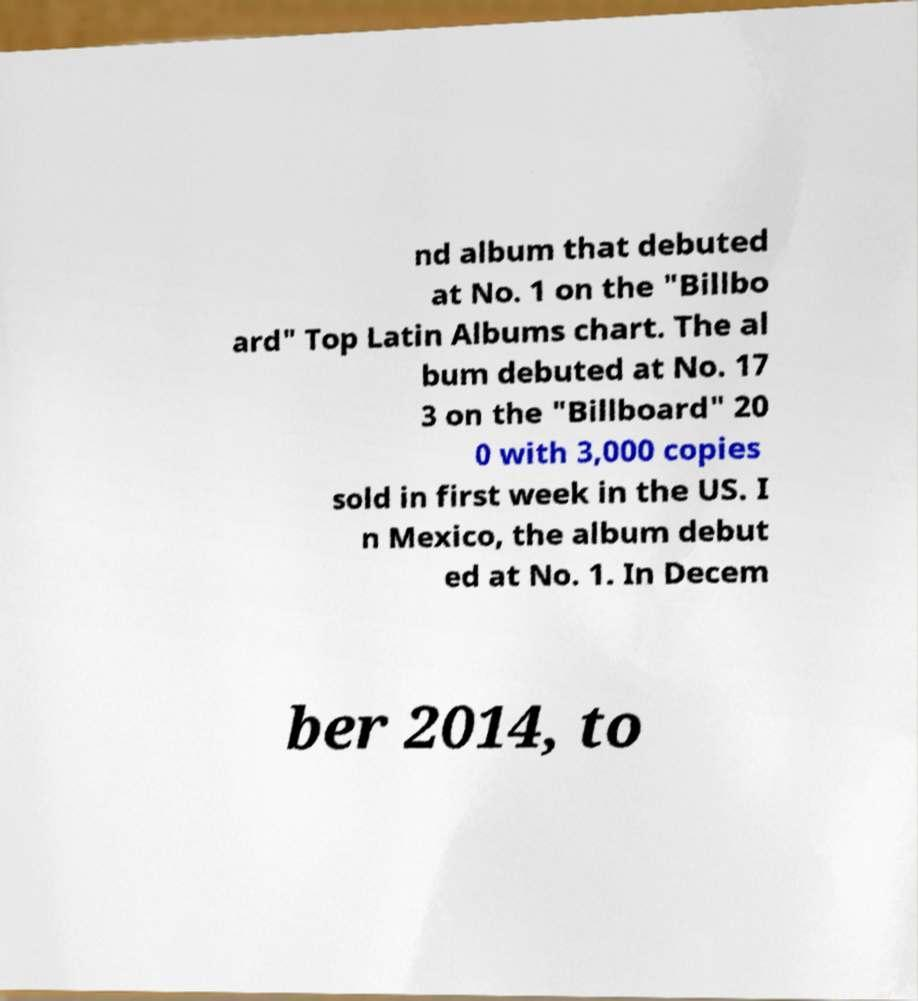What messages or text are displayed in this image? I need them in a readable, typed format. nd album that debuted at No. 1 on the "Billbo ard" Top Latin Albums chart. The al bum debuted at No. 17 3 on the "Billboard" 20 0 with 3,000 copies sold in first week in the US. I n Mexico, the album debut ed at No. 1. In Decem ber 2014, to 